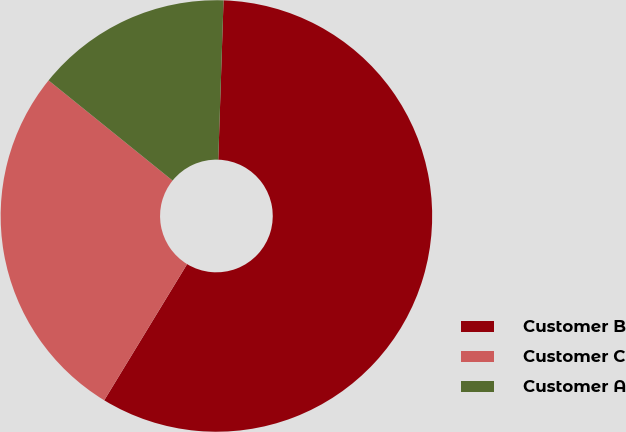Convert chart to OTSL. <chart><loc_0><loc_0><loc_500><loc_500><pie_chart><fcel>Customer B<fcel>Customer C<fcel>Customer A<nl><fcel>58.17%<fcel>27.11%<fcel>14.71%<nl></chart> 